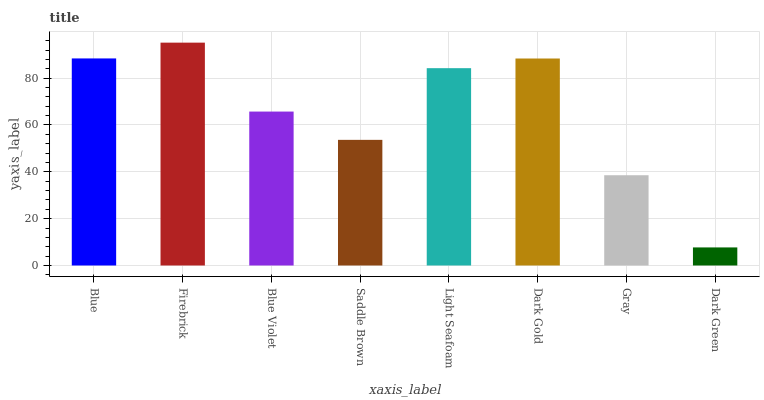Is Blue Violet the minimum?
Answer yes or no. No. Is Blue Violet the maximum?
Answer yes or no. No. Is Firebrick greater than Blue Violet?
Answer yes or no. Yes. Is Blue Violet less than Firebrick?
Answer yes or no. Yes. Is Blue Violet greater than Firebrick?
Answer yes or no. No. Is Firebrick less than Blue Violet?
Answer yes or no. No. Is Light Seafoam the high median?
Answer yes or no. Yes. Is Blue Violet the low median?
Answer yes or no. Yes. Is Firebrick the high median?
Answer yes or no. No. Is Dark Green the low median?
Answer yes or no. No. 